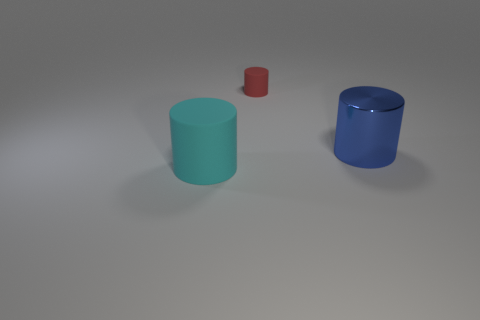Add 1 big matte objects. How many objects exist? 4 Subtract 0 purple cylinders. How many objects are left? 3 Subtract all small red rubber cylinders. Subtract all small objects. How many objects are left? 1 Add 3 big rubber cylinders. How many big rubber cylinders are left? 4 Add 2 small gray shiny spheres. How many small gray shiny spheres exist? 2 